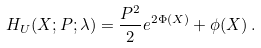Convert formula to latex. <formula><loc_0><loc_0><loc_500><loc_500>H _ { U } ( { X } ; { P } ; \lambda ) = \frac { { P } ^ { 2 } } { 2 } e ^ { 2 \Phi ( { X } ) } + \phi ( { X } ) \, .</formula> 